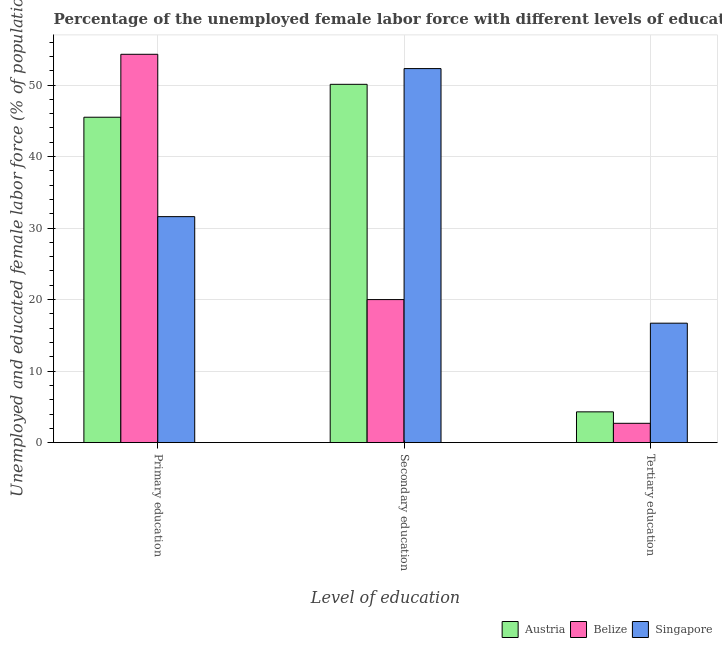How many groups of bars are there?
Offer a terse response. 3. Are the number of bars per tick equal to the number of legend labels?
Give a very brief answer. Yes. Are the number of bars on each tick of the X-axis equal?
Provide a short and direct response. Yes. What is the label of the 2nd group of bars from the left?
Give a very brief answer. Secondary education. What is the percentage of female labor force who received tertiary education in Belize?
Your answer should be very brief. 2.7. Across all countries, what is the maximum percentage of female labor force who received tertiary education?
Offer a terse response. 16.7. Across all countries, what is the minimum percentage of female labor force who received tertiary education?
Offer a terse response. 2.7. In which country was the percentage of female labor force who received secondary education maximum?
Your response must be concise. Singapore. In which country was the percentage of female labor force who received secondary education minimum?
Keep it short and to the point. Belize. What is the total percentage of female labor force who received tertiary education in the graph?
Offer a very short reply. 23.7. What is the difference between the percentage of female labor force who received tertiary education in Belize and that in Austria?
Your answer should be compact. -1.6. What is the difference between the percentage of female labor force who received secondary education in Singapore and the percentage of female labor force who received tertiary education in Belize?
Offer a terse response. 49.6. What is the average percentage of female labor force who received secondary education per country?
Your response must be concise. 40.8. What is the difference between the percentage of female labor force who received secondary education and percentage of female labor force who received primary education in Austria?
Offer a very short reply. 4.6. What is the ratio of the percentage of female labor force who received tertiary education in Austria to that in Singapore?
Offer a terse response. 0.26. Is the percentage of female labor force who received primary education in Belize less than that in Austria?
Offer a terse response. No. Is the difference between the percentage of female labor force who received tertiary education in Austria and Belize greater than the difference between the percentage of female labor force who received primary education in Austria and Belize?
Provide a short and direct response. Yes. What is the difference between the highest and the second highest percentage of female labor force who received secondary education?
Offer a very short reply. 2.2. What is the difference between the highest and the lowest percentage of female labor force who received secondary education?
Give a very brief answer. 32.3. In how many countries, is the percentage of female labor force who received tertiary education greater than the average percentage of female labor force who received tertiary education taken over all countries?
Your response must be concise. 1. Is the sum of the percentage of female labor force who received secondary education in Austria and Belize greater than the maximum percentage of female labor force who received tertiary education across all countries?
Keep it short and to the point. Yes. What does the 1st bar from the left in Tertiary education represents?
Offer a terse response. Austria. What does the 2nd bar from the right in Primary education represents?
Your response must be concise. Belize. Is it the case that in every country, the sum of the percentage of female labor force who received primary education and percentage of female labor force who received secondary education is greater than the percentage of female labor force who received tertiary education?
Keep it short and to the point. Yes. How many bars are there?
Your answer should be compact. 9. How many countries are there in the graph?
Your answer should be compact. 3. What is the difference between two consecutive major ticks on the Y-axis?
Make the answer very short. 10. Does the graph contain any zero values?
Make the answer very short. No. Where does the legend appear in the graph?
Make the answer very short. Bottom right. How many legend labels are there?
Your answer should be very brief. 3. How are the legend labels stacked?
Provide a succinct answer. Horizontal. What is the title of the graph?
Provide a short and direct response. Percentage of the unemployed female labor force with different levels of education in countries. What is the label or title of the X-axis?
Provide a short and direct response. Level of education. What is the label or title of the Y-axis?
Offer a very short reply. Unemployed and educated female labor force (% of population). What is the Unemployed and educated female labor force (% of population) in Austria in Primary education?
Your response must be concise. 45.5. What is the Unemployed and educated female labor force (% of population) of Belize in Primary education?
Provide a short and direct response. 54.3. What is the Unemployed and educated female labor force (% of population) in Singapore in Primary education?
Keep it short and to the point. 31.6. What is the Unemployed and educated female labor force (% of population) of Austria in Secondary education?
Provide a succinct answer. 50.1. What is the Unemployed and educated female labor force (% of population) of Singapore in Secondary education?
Your response must be concise. 52.3. What is the Unemployed and educated female labor force (% of population) in Austria in Tertiary education?
Ensure brevity in your answer.  4.3. What is the Unemployed and educated female labor force (% of population) of Belize in Tertiary education?
Ensure brevity in your answer.  2.7. What is the Unemployed and educated female labor force (% of population) in Singapore in Tertiary education?
Give a very brief answer. 16.7. Across all Level of education, what is the maximum Unemployed and educated female labor force (% of population) in Austria?
Your answer should be very brief. 50.1. Across all Level of education, what is the maximum Unemployed and educated female labor force (% of population) in Belize?
Your answer should be compact. 54.3. Across all Level of education, what is the maximum Unemployed and educated female labor force (% of population) in Singapore?
Your answer should be very brief. 52.3. Across all Level of education, what is the minimum Unemployed and educated female labor force (% of population) of Austria?
Make the answer very short. 4.3. Across all Level of education, what is the minimum Unemployed and educated female labor force (% of population) in Belize?
Keep it short and to the point. 2.7. Across all Level of education, what is the minimum Unemployed and educated female labor force (% of population) of Singapore?
Your response must be concise. 16.7. What is the total Unemployed and educated female labor force (% of population) of Austria in the graph?
Provide a succinct answer. 99.9. What is the total Unemployed and educated female labor force (% of population) of Belize in the graph?
Provide a succinct answer. 77. What is the total Unemployed and educated female labor force (% of population) of Singapore in the graph?
Keep it short and to the point. 100.6. What is the difference between the Unemployed and educated female labor force (% of population) of Austria in Primary education and that in Secondary education?
Offer a terse response. -4.6. What is the difference between the Unemployed and educated female labor force (% of population) in Belize in Primary education and that in Secondary education?
Offer a very short reply. 34.3. What is the difference between the Unemployed and educated female labor force (% of population) of Singapore in Primary education and that in Secondary education?
Provide a short and direct response. -20.7. What is the difference between the Unemployed and educated female labor force (% of population) of Austria in Primary education and that in Tertiary education?
Ensure brevity in your answer.  41.2. What is the difference between the Unemployed and educated female labor force (% of population) of Belize in Primary education and that in Tertiary education?
Your response must be concise. 51.6. What is the difference between the Unemployed and educated female labor force (% of population) in Singapore in Primary education and that in Tertiary education?
Your response must be concise. 14.9. What is the difference between the Unemployed and educated female labor force (% of population) in Austria in Secondary education and that in Tertiary education?
Ensure brevity in your answer.  45.8. What is the difference between the Unemployed and educated female labor force (% of population) in Singapore in Secondary education and that in Tertiary education?
Provide a succinct answer. 35.6. What is the difference between the Unemployed and educated female labor force (% of population) of Belize in Primary education and the Unemployed and educated female labor force (% of population) of Singapore in Secondary education?
Provide a succinct answer. 2. What is the difference between the Unemployed and educated female labor force (% of population) in Austria in Primary education and the Unemployed and educated female labor force (% of population) in Belize in Tertiary education?
Provide a succinct answer. 42.8. What is the difference between the Unemployed and educated female labor force (% of population) in Austria in Primary education and the Unemployed and educated female labor force (% of population) in Singapore in Tertiary education?
Your response must be concise. 28.8. What is the difference between the Unemployed and educated female labor force (% of population) of Belize in Primary education and the Unemployed and educated female labor force (% of population) of Singapore in Tertiary education?
Your response must be concise. 37.6. What is the difference between the Unemployed and educated female labor force (% of population) of Austria in Secondary education and the Unemployed and educated female labor force (% of population) of Belize in Tertiary education?
Give a very brief answer. 47.4. What is the difference between the Unemployed and educated female labor force (% of population) in Austria in Secondary education and the Unemployed and educated female labor force (% of population) in Singapore in Tertiary education?
Offer a very short reply. 33.4. What is the difference between the Unemployed and educated female labor force (% of population) of Belize in Secondary education and the Unemployed and educated female labor force (% of population) of Singapore in Tertiary education?
Your answer should be very brief. 3.3. What is the average Unemployed and educated female labor force (% of population) in Austria per Level of education?
Provide a short and direct response. 33.3. What is the average Unemployed and educated female labor force (% of population) in Belize per Level of education?
Ensure brevity in your answer.  25.67. What is the average Unemployed and educated female labor force (% of population) of Singapore per Level of education?
Give a very brief answer. 33.53. What is the difference between the Unemployed and educated female labor force (% of population) of Austria and Unemployed and educated female labor force (% of population) of Singapore in Primary education?
Offer a very short reply. 13.9. What is the difference between the Unemployed and educated female labor force (% of population) in Belize and Unemployed and educated female labor force (% of population) in Singapore in Primary education?
Your response must be concise. 22.7. What is the difference between the Unemployed and educated female labor force (% of population) in Austria and Unemployed and educated female labor force (% of population) in Belize in Secondary education?
Make the answer very short. 30.1. What is the difference between the Unemployed and educated female labor force (% of population) of Belize and Unemployed and educated female labor force (% of population) of Singapore in Secondary education?
Keep it short and to the point. -32.3. What is the difference between the Unemployed and educated female labor force (% of population) in Austria and Unemployed and educated female labor force (% of population) in Singapore in Tertiary education?
Keep it short and to the point. -12.4. What is the difference between the Unemployed and educated female labor force (% of population) of Belize and Unemployed and educated female labor force (% of population) of Singapore in Tertiary education?
Provide a short and direct response. -14. What is the ratio of the Unemployed and educated female labor force (% of population) of Austria in Primary education to that in Secondary education?
Provide a short and direct response. 0.91. What is the ratio of the Unemployed and educated female labor force (% of population) in Belize in Primary education to that in Secondary education?
Ensure brevity in your answer.  2.71. What is the ratio of the Unemployed and educated female labor force (% of population) in Singapore in Primary education to that in Secondary education?
Give a very brief answer. 0.6. What is the ratio of the Unemployed and educated female labor force (% of population) of Austria in Primary education to that in Tertiary education?
Your response must be concise. 10.58. What is the ratio of the Unemployed and educated female labor force (% of population) of Belize in Primary education to that in Tertiary education?
Ensure brevity in your answer.  20.11. What is the ratio of the Unemployed and educated female labor force (% of population) in Singapore in Primary education to that in Tertiary education?
Your response must be concise. 1.89. What is the ratio of the Unemployed and educated female labor force (% of population) of Austria in Secondary education to that in Tertiary education?
Provide a succinct answer. 11.65. What is the ratio of the Unemployed and educated female labor force (% of population) in Belize in Secondary education to that in Tertiary education?
Make the answer very short. 7.41. What is the ratio of the Unemployed and educated female labor force (% of population) of Singapore in Secondary education to that in Tertiary education?
Your answer should be compact. 3.13. What is the difference between the highest and the second highest Unemployed and educated female labor force (% of population) of Belize?
Give a very brief answer. 34.3. What is the difference between the highest and the second highest Unemployed and educated female labor force (% of population) in Singapore?
Give a very brief answer. 20.7. What is the difference between the highest and the lowest Unemployed and educated female labor force (% of population) in Austria?
Offer a very short reply. 45.8. What is the difference between the highest and the lowest Unemployed and educated female labor force (% of population) in Belize?
Offer a terse response. 51.6. What is the difference between the highest and the lowest Unemployed and educated female labor force (% of population) of Singapore?
Your answer should be very brief. 35.6. 